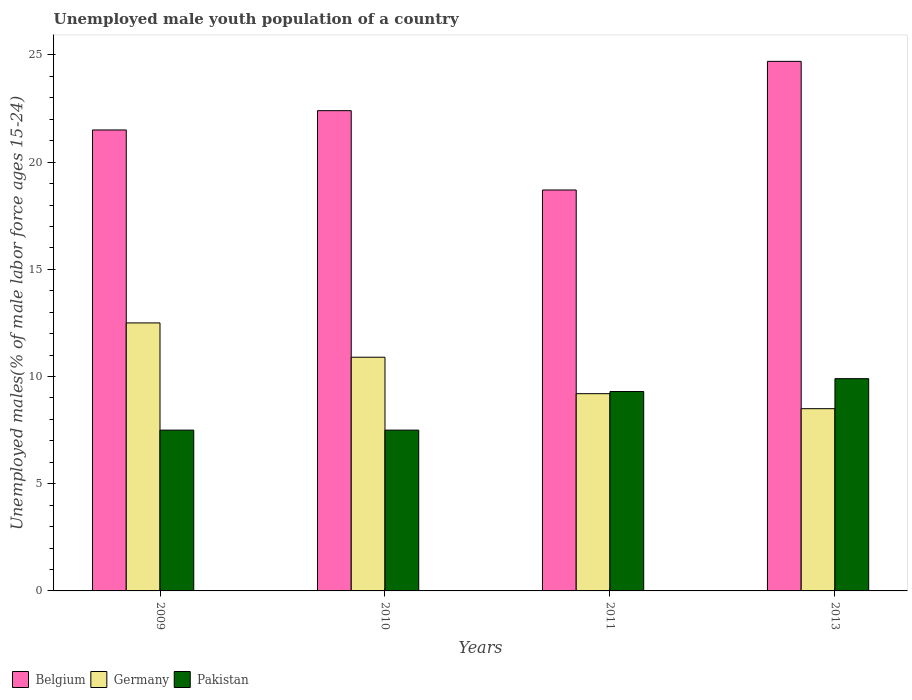How many bars are there on the 4th tick from the left?
Ensure brevity in your answer.  3. In how many cases, is the number of bars for a given year not equal to the number of legend labels?
Make the answer very short. 0. What is the percentage of unemployed male youth population in Belgium in 2010?
Your answer should be very brief. 22.4. Across all years, what is the maximum percentage of unemployed male youth population in Belgium?
Your answer should be compact. 24.7. Across all years, what is the minimum percentage of unemployed male youth population in Belgium?
Provide a short and direct response. 18.7. In which year was the percentage of unemployed male youth population in Germany minimum?
Offer a very short reply. 2013. What is the total percentage of unemployed male youth population in Pakistan in the graph?
Make the answer very short. 34.2. What is the difference between the percentage of unemployed male youth population in Germany in 2011 and the percentage of unemployed male youth population in Pakistan in 2010?
Your answer should be compact. 1.7. What is the average percentage of unemployed male youth population in Belgium per year?
Your response must be concise. 21.83. In the year 2010, what is the difference between the percentage of unemployed male youth population in Germany and percentage of unemployed male youth population in Belgium?
Offer a very short reply. -11.5. What is the ratio of the percentage of unemployed male youth population in Pakistan in 2009 to that in 2011?
Keep it short and to the point. 0.81. Is the percentage of unemployed male youth population in Pakistan in 2011 less than that in 2013?
Offer a very short reply. Yes. What is the difference between the highest and the second highest percentage of unemployed male youth population in Germany?
Your answer should be very brief. 1.6. What is the difference between the highest and the lowest percentage of unemployed male youth population in Pakistan?
Your answer should be compact. 2.4. In how many years, is the percentage of unemployed male youth population in Pakistan greater than the average percentage of unemployed male youth population in Pakistan taken over all years?
Offer a very short reply. 2. Is the sum of the percentage of unemployed male youth population in Pakistan in 2009 and 2013 greater than the maximum percentage of unemployed male youth population in Germany across all years?
Your response must be concise. Yes. What does the 1st bar from the left in 2011 represents?
Give a very brief answer. Belgium. Is it the case that in every year, the sum of the percentage of unemployed male youth population in Belgium and percentage of unemployed male youth population in Germany is greater than the percentage of unemployed male youth population in Pakistan?
Give a very brief answer. Yes. How many bars are there?
Keep it short and to the point. 12. Are all the bars in the graph horizontal?
Provide a short and direct response. No. How many years are there in the graph?
Keep it short and to the point. 4. What is the difference between two consecutive major ticks on the Y-axis?
Ensure brevity in your answer.  5. Does the graph contain grids?
Give a very brief answer. No. Where does the legend appear in the graph?
Your answer should be compact. Bottom left. How many legend labels are there?
Your answer should be very brief. 3. How are the legend labels stacked?
Your answer should be very brief. Horizontal. What is the title of the graph?
Keep it short and to the point. Unemployed male youth population of a country. Does "Cote d'Ivoire" appear as one of the legend labels in the graph?
Your answer should be compact. No. What is the label or title of the Y-axis?
Make the answer very short. Unemployed males(% of male labor force ages 15-24). What is the Unemployed males(% of male labor force ages 15-24) in Germany in 2009?
Offer a very short reply. 12.5. What is the Unemployed males(% of male labor force ages 15-24) of Belgium in 2010?
Offer a terse response. 22.4. What is the Unemployed males(% of male labor force ages 15-24) in Germany in 2010?
Make the answer very short. 10.9. What is the Unemployed males(% of male labor force ages 15-24) in Pakistan in 2010?
Your response must be concise. 7.5. What is the Unemployed males(% of male labor force ages 15-24) in Belgium in 2011?
Offer a very short reply. 18.7. What is the Unemployed males(% of male labor force ages 15-24) of Germany in 2011?
Keep it short and to the point. 9.2. What is the Unemployed males(% of male labor force ages 15-24) of Pakistan in 2011?
Make the answer very short. 9.3. What is the Unemployed males(% of male labor force ages 15-24) of Belgium in 2013?
Offer a terse response. 24.7. What is the Unemployed males(% of male labor force ages 15-24) of Germany in 2013?
Offer a very short reply. 8.5. What is the Unemployed males(% of male labor force ages 15-24) in Pakistan in 2013?
Your answer should be compact. 9.9. Across all years, what is the maximum Unemployed males(% of male labor force ages 15-24) of Belgium?
Your answer should be very brief. 24.7. Across all years, what is the maximum Unemployed males(% of male labor force ages 15-24) of Pakistan?
Give a very brief answer. 9.9. Across all years, what is the minimum Unemployed males(% of male labor force ages 15-24) of Belgium?
Your answer should be compact. 18.7. Across all years, what is the minimum Unemployed males(% of male labor force ages 15-24) in Germany?
Your answer should be very brief. 8.5. What is the total Unemployed males(% of male labor force ages 15-24) in Belgium in the graph?
Offer a terse response. 87.3. What is the total Unemployed males(% of male labor force ages 15-24) in Germany in the graph?
Offer a very short reply. 41.1. What is the total Unemployed males(% of male labor force ages 15-24) of Pakistan in the graph?
Your answer should be compact. 34.2. What is the difference between the Unemployed males(% of male labor force ages 15-24) of Belgium in 2009 and that in 2010?
Offer a very short reply. -0.9. What is the difference between the Unemployed males(% of male labor force ages 15-24) of Pakistan in 2009 and that in 2010?
Your answer should be very brief. 0. What is the difference between the Unemployed males(% of male labor force ages 15-24) in Belgium in 2009 and that in 2011?
Offer a very short reply. 2.8. What is the difference between the Unemployed males(% of male labor force ages 15-24) of Germany in 2009 and that in 2011?
Offer a very short reply. 3.3. What is the difference between the Unemployed males(% of male labor force ages 15-24) in Pakistan in 2009 and that in 2011?
Your response must be concise. -1.8. What is the difference between the Unemployed males(% of male labor force ages 15-24) of Germany in 2009 and that in 2013?
Keep it short and to the point. 4. What is the difference between the Unemployed males(% of male labor force ages 15-24) of Belgium in 2010 and that in 2011?
Keep it short and to the point. 3.7. What is the difference between the Unemployed males(% of male labor force ages 15-24) of Germany in 2010 and that in 2011?
Your response must be concise. 1.7. What is the difference between the Unemployed males(% of male labor force ages 15-24) in Germany in 2010 and that in 2013?
Offer a very short reply. 2.4. What is the difference between the Unemployed males(% of male labor force ages 15-24) of Belgium in 2009 and the Unemployed males(% of male labor force ages 15-24) of Germany in 2010?
Offer a terse response. 10.6. What is the difference between the Unemployed males(% of male labor force ages 15-24) in Belgium in 2009 and the Unemployed males(% of male labor force ages 15-24) in Pakistan in 2010?
Provide a short and direct response. 14. What is the difference between the Unemployed males(% of male labor force ages 15-24) of Belgium in 2009 and the Unemployed males(% of male labor force ages 15-24) of Pakistan in 2011?
Offer a very short reply. 12.2. What is the difference between the Unemployed males(% of male labor force ages 15-24) in Belgium in 2010 and the Unemployed males(% of male labor force ages 15-24) in Pakistan in 2011?
Make the answer very short. 13.1. What is the difference between the Unemployed males(% of male labor force ages 15-24) in Germany in 2010 and the Unemployed males(% of male labor force ages 15-24) in Pakistan in 2011?
Keep it short and to the point. 1.6. What is the difference between the Unemployed males(% of male labor force ages 15-24) in Belgium in 2010 and the Unemployed males(% of male labor force ages 15-24) in Germany in 2013?
Provide a succinct answer. 13.9. What is the difference between the Unemployed males(% of male labor force ages 15-24) in Belgium in 2010 and the Unemployed males(% of male labor force ages 15-24) in Pakistan in 2013?
Provide a succinct answer. 12.5. What is the difference between the Unemployed males(% of male labor force ages 15-24) of Germany in 2010 and the Unemployed males(% of male labor force ages 15-24) of Pakistan in 2013?
Ensure brevity in your answer.  1. What is the difference between the Unemployed males(% of male labor force ages 15-24) of Germany in 2011 and the Unemployed males(% of male labor force ages 15-24) of Pakistan in 2013?
Offer a terse response. -0.7. What is the average Unemployed males(% of male labor force ages 15-24) of Belgium per year?
Your answer should be compact. 21.82. What is the average Unemployed males(% of male labor force ages 15-24) of Germany per year?
Provide a succinct answer. 10.28. What is the average Unemployed males(% of male labor force ages 15-24) of Pakistan per year?
Offer a terse response. 8.55. In the year 2009, what is the difference between the Unemployed males(% of male labor force ages 15-24) of Belgium and Unemployed males(% of male labor force ages 15-24) of Germany?
Your answer should be compact. 9. In the year 2009, what is the difference between the Unemployed males(% of male labor force ages 15-24) of Germany and Unemployed males(% of male labor force ages 15-24) of Pakistan?
Your answer should be very brief. 5. In the year 2011, what is the difference between the Unemployed males(% of male labor force ages 15-24) of Belgium and Unemployed males(% of male labor force ages 15-24) of Germany?
Your answer should be compact. 9.5. In the year 2011, what is the difference between the Unemployed males(% of male labor force ages 15-24) in Belgium and Unemployed males(% of male labor force ages 15-24) in Pakistan?
Provide a succinct answer. 9.4. In the year 2013, what is the difference between the Unemployed males(% of male labor force ages 15-24) in Belgium and Unemployed males(% of male labor force ages 15-24) in Germany?
Your response must be concise. 16.2. In the year 2013, what is the difference between the Unemployed males(% of male labor force ages 15-24) in Germany and Unemployed males(% of male labor force ages 15-24) in Pakistan?
Offer a terse response. -1.4. What is the ratio of the Unemployed males(% of male labor force ages 15-24) in Belgium in 2009 to that in 2010?
Your answer should be very brief. 0.96. What is the ratio of the Unemployed males(% of male labor force ages 15-24) of Germany in 2009 to that in 2010?
Provide a succinct answer. 1.15. What is the ratio of the Unemployed males(% of male labor force ages 15-24) of Belgium in 2009 to that in 2011?
Ensure brevity in your answer.  1.15. What is the ratio of the Unemployed males(% of male labor force ages 15-24) in Germany in 2009 to that in 2011?
Provide a short and direct response. 1.36. What is the ratio of the Unemployed males(% of male labor force ages 15-24) of Pakistan in 2009 to that in 2011?
Offer a very short reply. 0.81. What is the ratio of the Unemployed males(% of male labor force ages 15-24) of Belgium in 2009 to that in 2013?
Offer a very short reply. 0.87. What is the ratio of the Unemployed males(% of male labor force ages 15-24) in Germany in 2009 to that in 2013?
Ensure brevity in your answer.  1.47. What is the ratio of the Unemployed males(% of male labor force ages 15-24) of Pakistan in 2009 to that in 2013?
Your response must be concise. 0.76. What is the ratio of the Unemployed males(% of male labor force ages 15-24) of Belgium in 2010 to that in 2011?
Offer a very short reply. 1.2. What is the ratio of the Unemployed males(% of male labor force ages 15-24) in Germany in 2010 to that in 2011?
Keep it short and to the point. 1.18. What is the ratio of the Unemployed males(% of male labor force ages 15-24) of Pakistan in 2010 to that in 2011?
Keep it short and to the point. 0.81. What is the ratio of the Unemployed males(% of male labor force ages 15-24) in Belgium in 2010 to that in 2013?
Offer a very short reply. 0.91. What is the ratio of the Unemployed males(% of male labor force ages 15-24) of Germany in 2010 to that in 2013?
Your response must be concise. 1.28. What is the ratio of the Unemployed males(% of male labor force ages 15-24) in Pakistan in 2010 to that in 2013?
Make the answer very short. 0.76. What is the ratio of the Unemployed males(% of male labor force ages 15-24) in Belgium in 2011 to that in 2013?
Provide a short and direct response. 0.76. What is the ratio of the Unemployed males(% of male labor force ages 15-24) of Germany in 2011 to that in 2013?
Ensure brevity in your answer.  1.08. What is the ratio of the Unemployed males(% of male labor force ages 15-24) of Pakistan in 2011 to that in 2013?
Your response must be concise. 0.94. What is the difference between the highest and the second highest Unemployed males(% of male labor force ages 15-24) of Belgium?
Offer a very short reply. 2.3. What is the difference between the highest and the second highest Unemployed males(% of male labor force ages 15-24) in Germany?
Provide a short and direct response. 1.6. What is the difference between the highest and the lowest Unemployed males(% of male labor force ages 15-24) in Belgium?
Your answer should be very brief. 6. What is the difference between the highest and the lowest Unemployed males(% of male labor force ages 15-24) of Germany?
Provide a short and direct response. 4. 